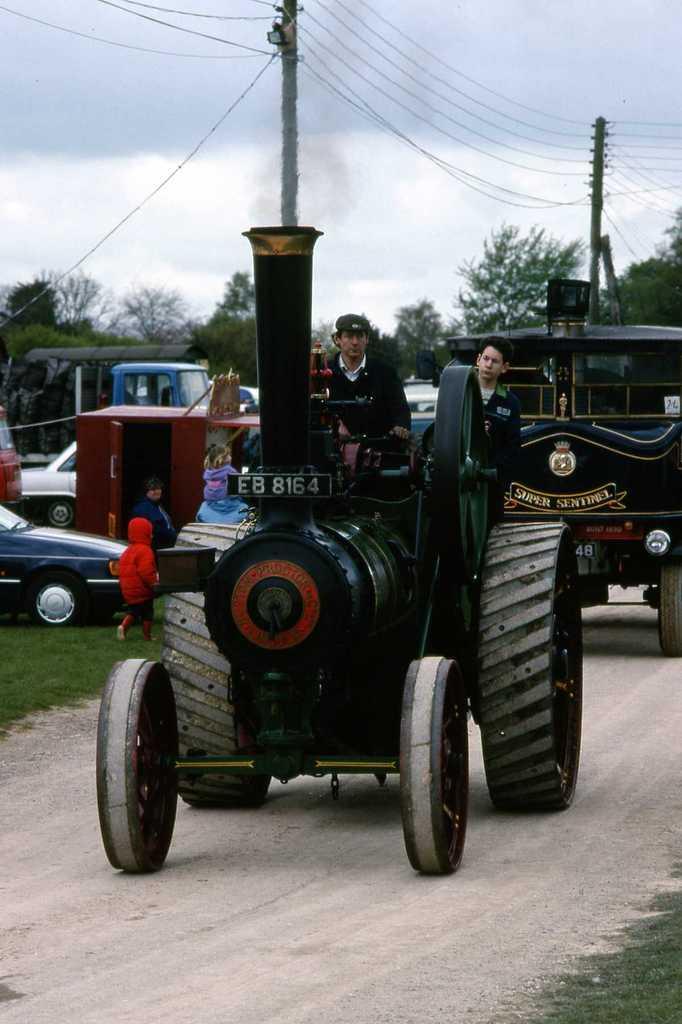In one or two sentences, can you explain what this image depicts? In this image we can see vehicles and there are people sitting in the vehicles. In the background there are trees, wires, poles and sky. On the left there are kids. 